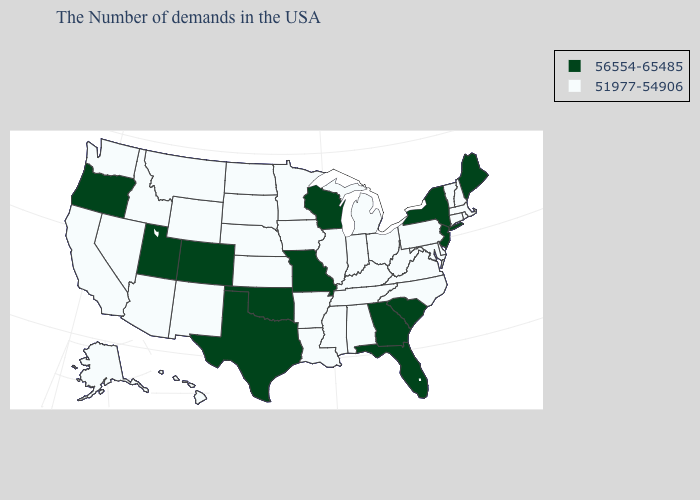Does the first symbol in the legend represent the smallest category?
Answer briefly. No. What is the value of Alabama?
Quick response, please. 51977-54906. Name the states that have a value in the range 56554-65485?
Write a very short answer. Maine, New York, New Jersey, South Carolina, Florida, Georgia, Wisconsin, Missouri, Oklahoma, Texas, Colorado, Utah, Oregon. What is the value of Wisconsin?
Concise answer only. 56554-65485. Does North Carolina have a lower value than Wisconsin?
Answer briefly. Yes. What is the value of Georgia?
Short answer required. 56554-65485. What is the value of Wisconsin?
Be succinct. 56554-65485. What is the value of North Carolina?
Give a very brief answer. 51977-54906. Is the legend a continuous bar?
Keep it brief. No. What is the value of Maine?
Give a very brief answer. 56554-65485. Among the states that border Kentucky , which have the lowest value?
Write a very short answer. Virginia, West Virginia, Ohio, Indiana, Tennessee, Illinois. Does Illinois have a lower value than Texas?
Concise answer only. Yes. Name the states that have a value in the range 56554-65485?
Give a very brief answer. Maine, New York, New Jersey, South Carolina, Florida, Georgia, Wisconsin, Missouri, Oklahoma, Texas, Colorado, Utah, Oregon. 